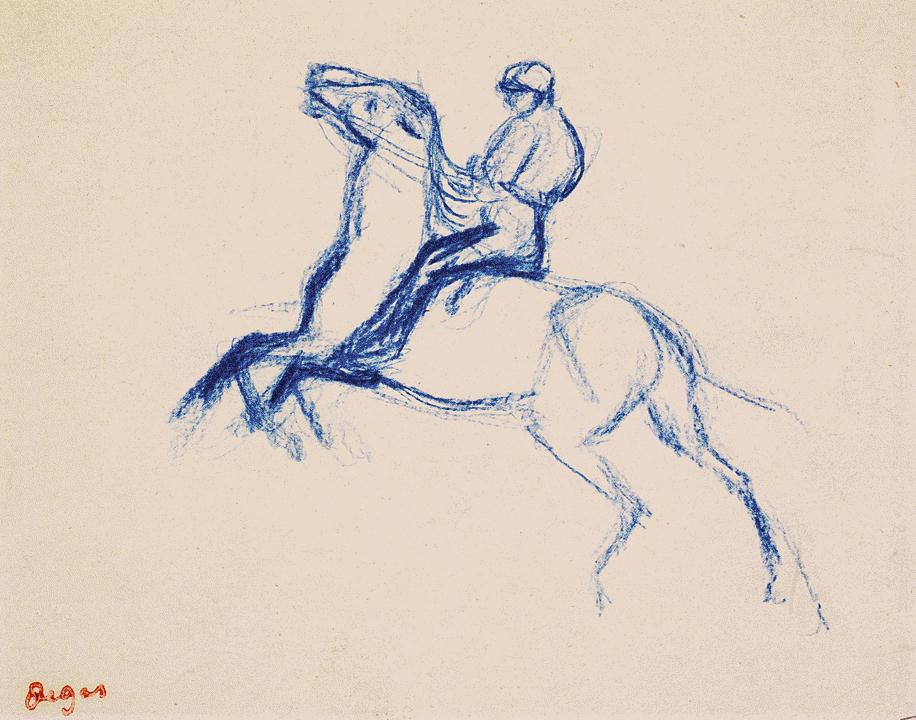What's the historical significance of equestrian art? Equestrian art has played a significant role throughout history, often symbolizing power, nobility, and the profound relationship between humans and horses. In ancient civilizations, horses were vital for transportation, agriculture, and warfare, making them a popular subject in art to denote status and prowess. Equestrian statues and paintings were used to glorify leaders and warriors, showcasing their command over these powerful animals. During the Renaissance and Baroque periods, equestrian portraits became a prominent genre, further emphasizing the rider's authority and elegance. The genre has evolved over time, but the core themes of reverence for the horse and the depiction of the intimate bond between rider and steed have remained a central focus. Can you tell a short story inspired by this image? Once upon a time, in a quaint village at the edge of a vast forest, there lived a young girl named Ella who dreamed of becoming a master equestrian. Every day, she trained diligently with her spirited horse, Azure, whose coat mirrored the deep blue of the ocean. Their bond was extraordinary, a testament to the countless hours spent together exploring the countryside. One crisp morning, as Ella and Azure galloped through the dew-kissed fields, they encountered a challenge: a mighty river they had never crossed before. Courageously, Azure reared up, his powerful legs propelling them into the air, and with a rush of wind and water, they soared across to the other side. From that day forward, every leap and bound became a symbol of their unbreakable unity and unyielding spirit, illustrating an extraordinary journey of trust and bravery. 